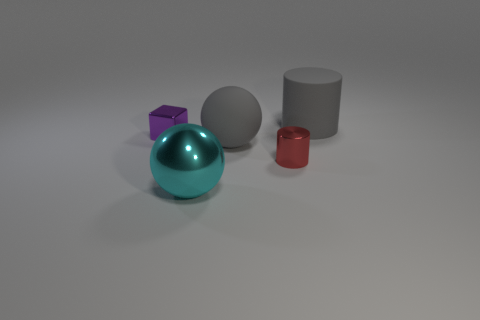Subtract 1 spheres. How many spheres are left? 1 Add 5 small yellow matte things. How many objects exist? 10 Subtract 0 brown cylinders. How many objects are left? 5 Subtract all spheres. How many objects are left? 3 Subtract all cyan cylinders. Subtract all red balls. How many cylinders are left? 2 Subtract all large green balls. Subtract all rubber cylinders. How many objects are left? 4 Add 4 tiny red metallic cylinders. How many tiny red metallic cylinders are left? 5 Add 2 gray cylinders. How many gray cylinders exist? 3 